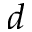<formula> <loc_0><loc_0><loc_500><loc_500>d</formula> 